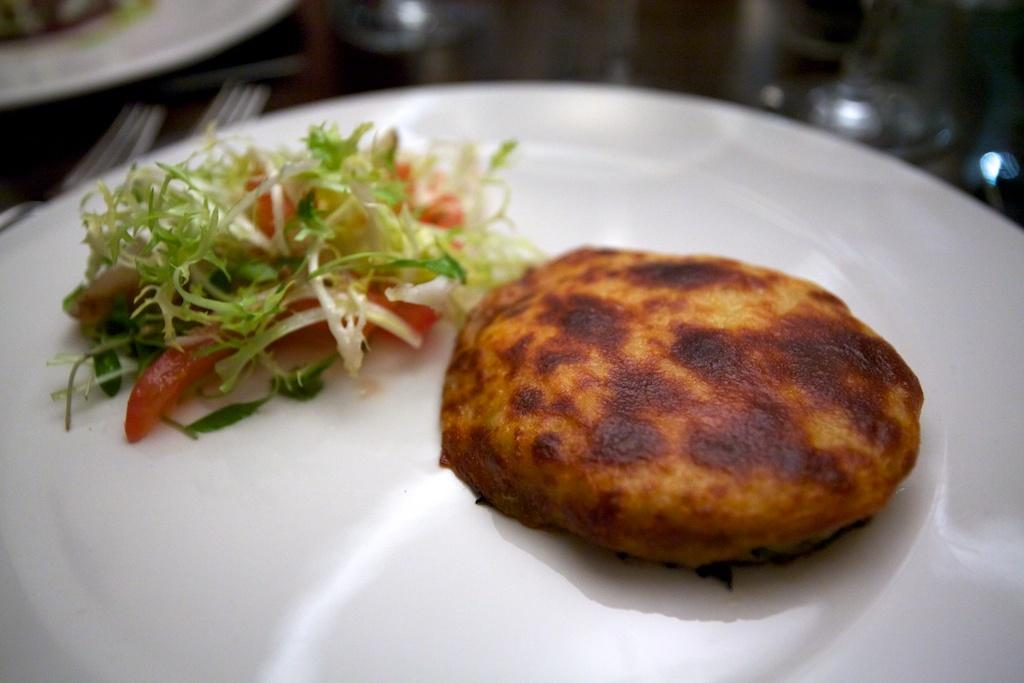What is present on the table in the image? There are plates and forks on a table in the image. What is on the plates in the image? There are food items served on plates in the plates in the image. What type of yard can be seen in the image? There is no yard present in the image; it features a table with plates and forks. What type of doll is sitting on the table in the image? There is no doll present in the image; it features a table with plates and forks. 